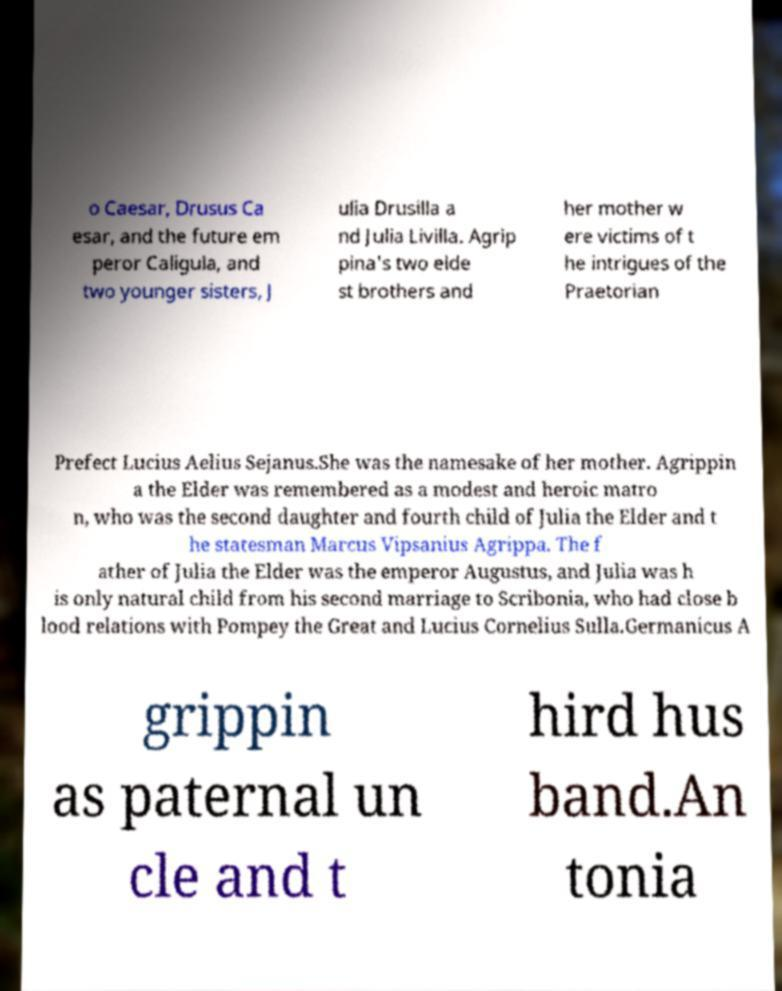For documentation purposes, I need the text within this image transcribed. Could you provide that? o Caesar, Drusus Ca esar, and the future em peror Caligula, and two younger sisters, J ulia Drusilla a nd Julia Livilla. Agrip pina's two elde st brothers and her mother w ere victims of t he intrigues of the Praetorian Prefect Lucius Aelius Sejanus.She was the namesake of her mother. Agrippin a the Elder was remembered as a modest and heroic matro n, who was the second daughter and fourth child of Julia the Elder and t he statesman Marcus Vipsanius Agrippa. The f ather of Julia the Elder was the emperor Augustus, and Julia was h is only natural child from his second marriage to Scribonia, who had close b lood relations with Pompey the Great and Lucius Cornelius Sulla.Germanicus A grippin as paternal un cle and t hird hus band.An tonia 